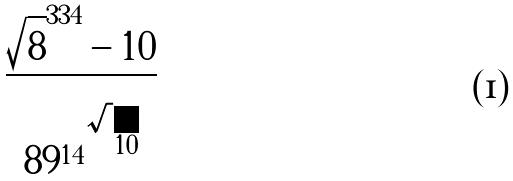Convert formula to latex. <formula><loc_0><loc_0><loc_500><loc_500>\frac { \sqrt { 8 } ^ { 3 3 4 } - 1 0 } { { 8 9 ^ { 1 4 } } ^ { \sqrt { 1 0 } } }</formula> 